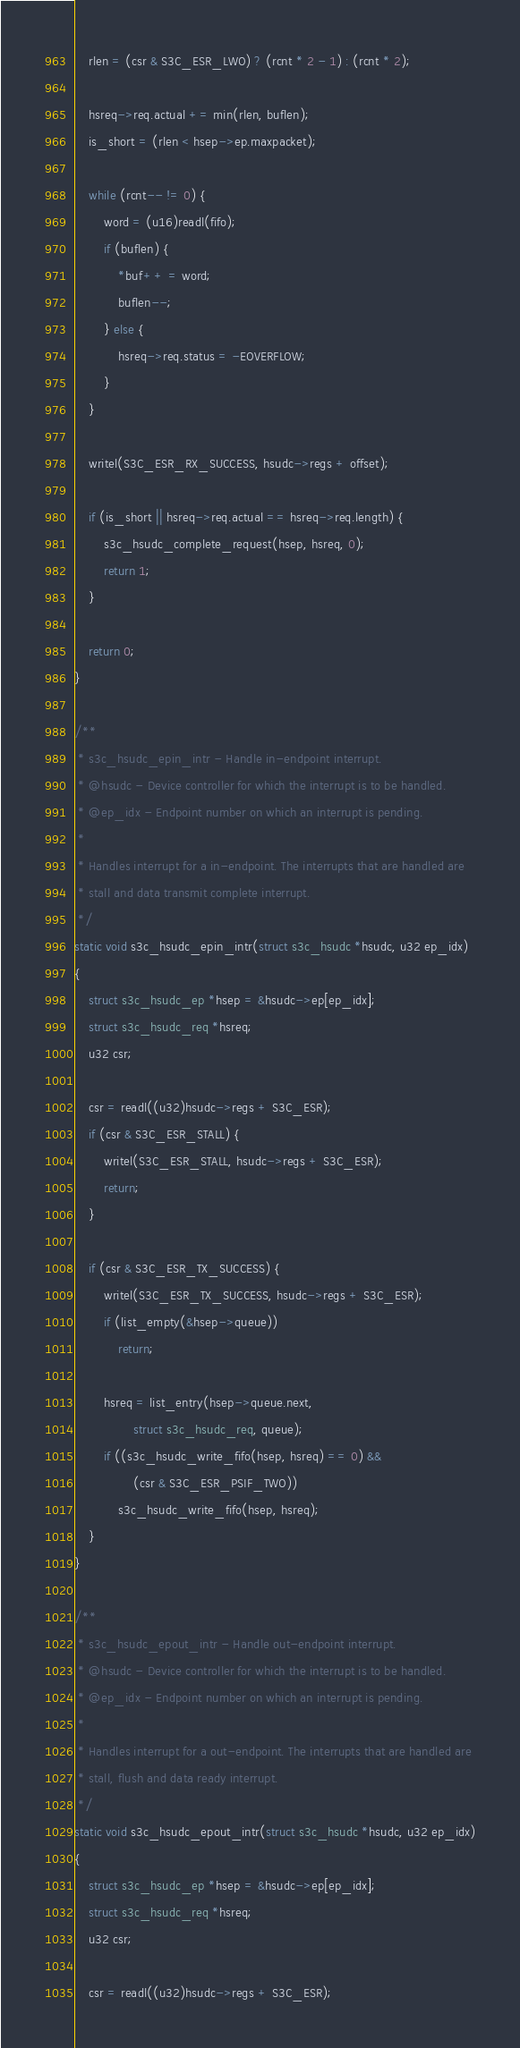<code> <loc_0><loc_0><loc_500><loc_500><_C_>	rlen = (csr & S3C_ESR_LWO) ? (rcnt * 2 - 1) : (rcnt * 2);

	hsreq->req.actual += min(rlen, buflen);
	is_short = (rlen < hsep->ep.maxpacket);

	while (rcnt-- != 0) {
		word = (u16)readl(fifo);
		if (buflen) {
			*buf++ = word;
			buflen--;
		} else {
			hsreq->req.status = -EOVERFLOW;
		}
	}

	writel(S3C_ESR_RX_SUCCESS, hsudc->regs + offset);

	if (is_short || hsreq->req.actual == hsreq->req.length) {
		s3c_hsudc_complete_request(hsep, hsreq, 0);
		return 1;
	}

	return 0;
}

/**
 * s3c_hsudc_epin_intr - Handle in-endpoint interrupt.
 * @hsudc - Device controller for which the interrupt is to be handled.
 * @ep_idx - Endpoint number on which an interrupt is pending.
 *
 * Handles interrupt for a in-endpoint. The interrupts that are handled are
 * stall and data transmit complete interrupt.
 */
static void s3c_hsudc_epin_intr(struct s3c_hsudc *hsudc, u32 ep_idx)
{
	struct s3c_hsudc_ep *hsep = &hsudc->ep[ep_idx];
	struct s3c_hsudc_req *hsreq;
	u32 csr;

	csr = readl((u32)hsudc->regs + S3C_ESR);
	if (csr & S3C_ESR_STALL) {
		writel(S3C_ESR_STALL, hsudc->regs + S3C_ESR);
		return;
	}

	if (csr & S3C_ESR_TX_SUCCESS) {
		writel(S3C_ESR_TX_SUCCESS, hsudc->regs + S3C_ESR);
		if (list_empty(&hsep->queue))
			return;

		hsreq = list_entry(hsep->queue.next,
				struct s3c_hsudc_req, queue);
		if ((s3c_hsudc_write_fifo(hsep, hsreq) == 0) &&
				(csr & S3C_ESR_PSIF_TWO))
			s3c_hsudc_write_fifo(hsep, hsreq);
	}
}

/**
 * s3c_hsudc_epout_intr - Handle out-endpoint interrupt.
 * @hsudc - Device controller for which the interrupt is to be handled.
 * @ep_idx - Endpoint number on which an interrupt is pending.
 *
 * Handles interrupt for a out-endpoint. The interrupts that are handled are
 * stall, flush and data ready interrupt.
 */
static void s3c_hsudc_epout_intr(struct s3c_hsudc *hsudc, u32 ep_idx)
{
	struct s3c_hsudc_ep *hsep = &hsudc->ep[ep_idx];
	struct s3c_hsudc_req *hsreq;
	u32 csr;

	csr = readl((u32)hsudc->regs + S3C_ESR);</code> 